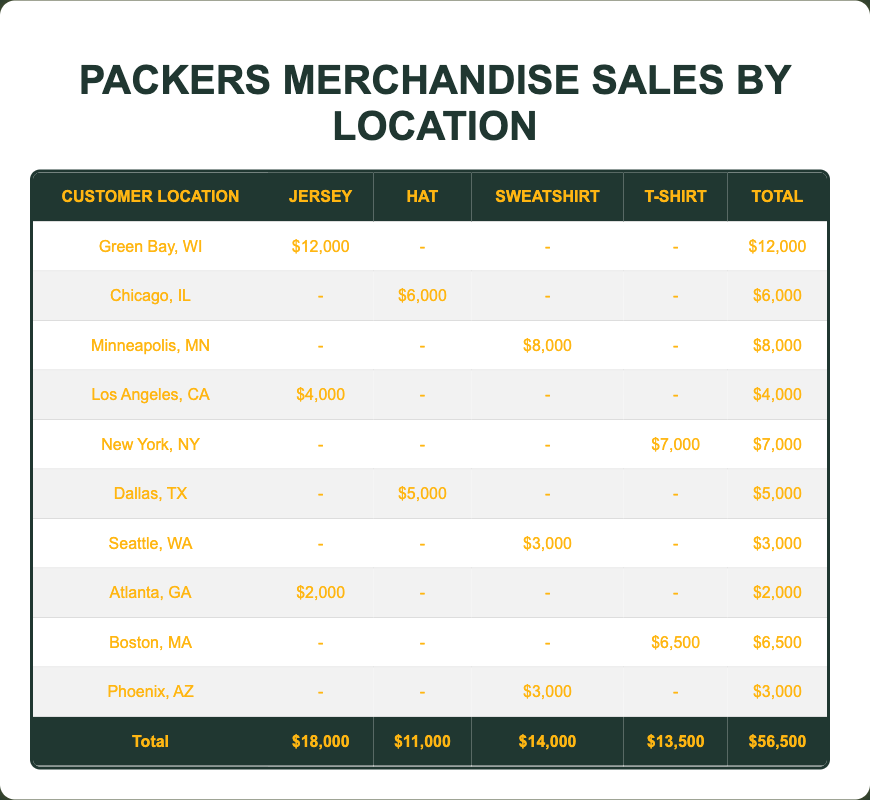What is the total sales amount for merchandise sold in Green Bay, WI? The sales amount for merchandise sold in Green Bay is located on the corresponding row for that location in the table. The value is $12,000.
Answer: $12,000 Which location had the highest sales amount for jerseys? Looking at the Jersey column, Green Bay, WI has the only value of $12,000, which is higher than any other location.
Answer: Green Bay, WI What is the combined total sales amount for hats sold in Chicago, IL and Dallas, TX? The sales amount for hats in Chicago, IL is $6,000 and for Dallas, TX it is $5,000. Adding these two amounts together gives us 6,000 + 5,000 = $11,000.
Answer: $11,000 Is there any location where sweatshirts sold more than $5,000? By looking at the Sweatshirt column, the only amounts are $8,000 (Minneapolis, MN), $3,000 (Seattle, WA), and $3,000 (Phoenix, AZ). Since none of these exceed $5,000, the answer is no.
Answer: No Which merchandise type sold the least amount in total? Total sales for each merchandise type are Jersey ($18,000), Hat ($11,000), Sweatshirt ($14,000), and T-shirt ($13,500). By comparing these totals, the Hats have the least sales amount at $11,000.
Answer: Hat What is the total sales amount for merchandise from locations west of the Mississippi River? The locations west of the Mississippi include Green Bay, WI (not included), Los Angeles, CA ($4,000), Minneapolis, MN ($8,000), Seattle, WA ($3,000), Dallas, TX ($5,000), and Phoenix, AZ ($3,000). The total sales from these locations is 4,000 + 8,000 + 3,000 + 5,000 + 3,000 = $23,000.
Answer: $23,000 Which location sold more T-shirts: New York, NY or Boston, MA? New York, NY sold T-shirts for $7,000, while Boston, MA sold T-shirts for $6,500. Since $7,000 is greater, New York, NY sold more T-shirts.
Answer: New York, NY What is the average sales amount for sweatshirts sold across all locations? The total sales for sweatshirts is $8,000 (Minneapolis, MN) + $3,000 (Seattle, WA) + $3,000 (Phoenix, AZ) = $14,000 for 3 locations, so the average is 14,000 / 3 = $4,666.67.
Answer: $4,666.67 Which merchandise type has only been sold in one location? Looking at the table, Jerseys are sold only in Green Bay, WI, while all other merchandise types are sold in multiple locations.
Answer: Jersey 